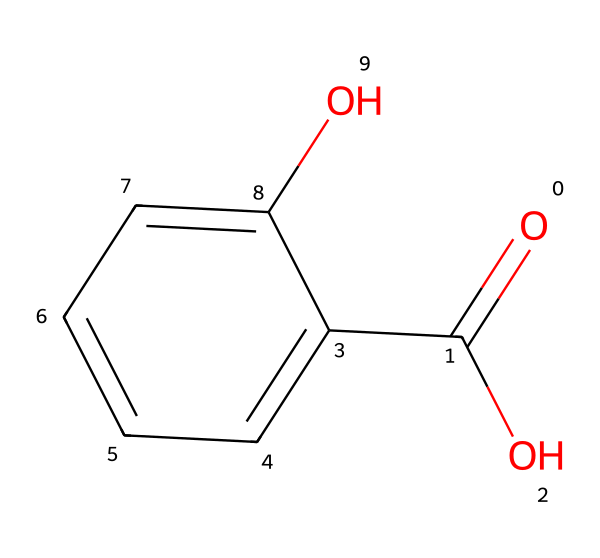What is the molecular formula of salicylic acid? To determine the molecular formula, count the number of carbon (C), hydrogen (H), and oxygen (O) atoms in the structure. There are 7 carbon atoms, 6 hydrogen atoms, and 3 oxygen atoms, leading to the formula C7H6O3.
Answer: C7H6O3 How many hydroxyl (-OH) groups are present in the structure? Examining the structure reveals one hydroxyl (-OH) group attached to the benzene ring and another hydroxyl group as part of the carboxylic acid functional group. In total, there are two -OH groups.
Answer: 2 What type of functional groups are found in salicylic acid? Analyzing the structure, you can identify a carboxylic acid functional group (O=C(O)) and a hydroxyl group (-OH). These are the two primary functional groups present.
Answer: carboxylic acid and hydroxyl What is the significance of the aromatic ring in salicylic acid? The aromatic ring (c1ccccc1) contributes to the stability and hydrophobic characteristics of salicylic acid. This structural feature allows it to penetrate skin effectively, making it useful in acne treatments.
Answer: stability and penetration What distinguishes salicylic acid from other common acne treatments? Salicylic acid is a beta hydroxy acid that can penetrate oil in pores, unlike most alpha hydroxy acids, which primarily exfoliate the skin's surface. This differentiates its mechanism of action from typical treatments.
Answer: deeper pore penetration How does the presence of the carboxylic acid group influence salicylic acid’s solubility? The carboxylic acid group contributes to salicylic acid's ability to ionize in solution, enhancing its water solubility compared to purely hydrophobic compounds. This solubility is important for its effectiveness in formulations.
Answer: increases solubility 